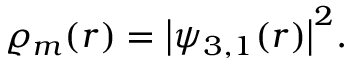<formula> <loc_0><loc_0><loc_500><loc_500>\varrho _ { m } ( r ) = \left | \psi _ { 3 , 1 } ( r ) \right | ^ { 2 } .</formula> 